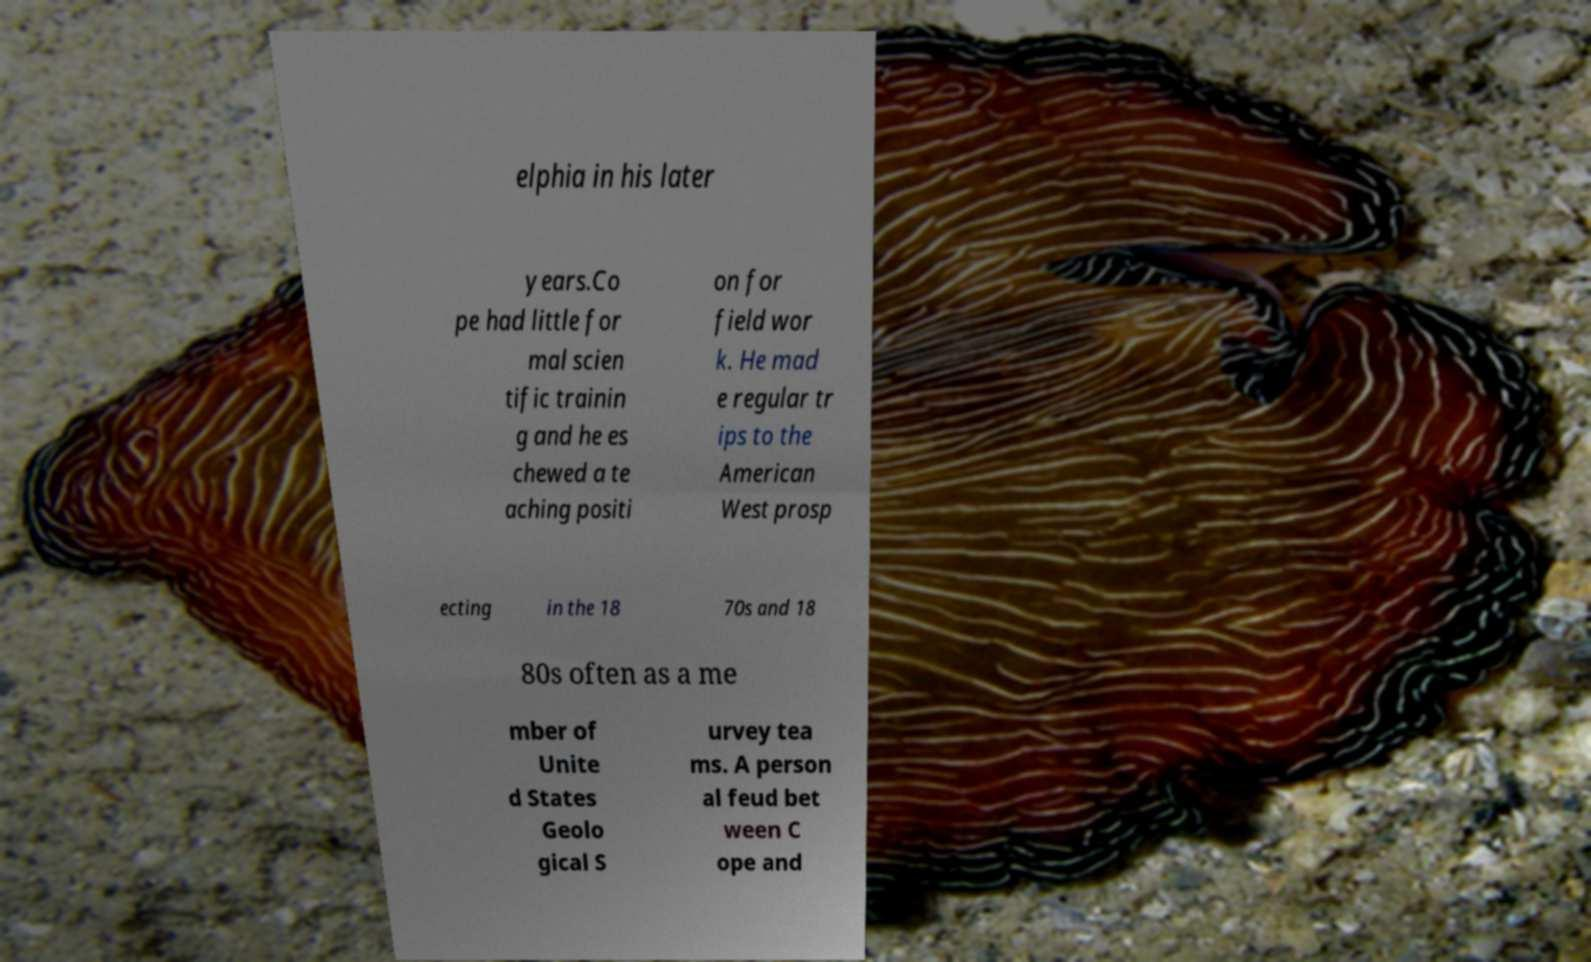Can you accurately transcribe the text from the provided image for me? elphia in his later years.Co pe had little for mal scien tific trainin g and he es chewed a te aching positi on for field wor k. He mad e regular tr ips to the American West prosp ecting in the 18 70s and 18 80s often as a me mber of Unite d States Geolo gical S urvey tea ms. A person al feud bet ween C ope and 